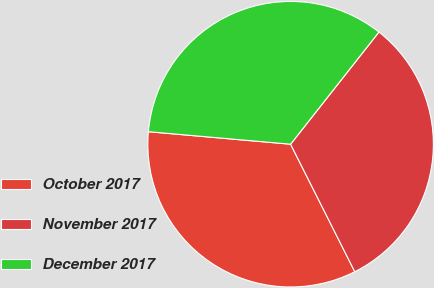<chart> <loc_0><loc_0><loc_500><loc_500><pie_chart><fcel>October 2017<fcel>November 2017<fcel>December 2017<nl><fcel>33.82%<fcel>31.96%<fcel>34.22%<nl></chart> 